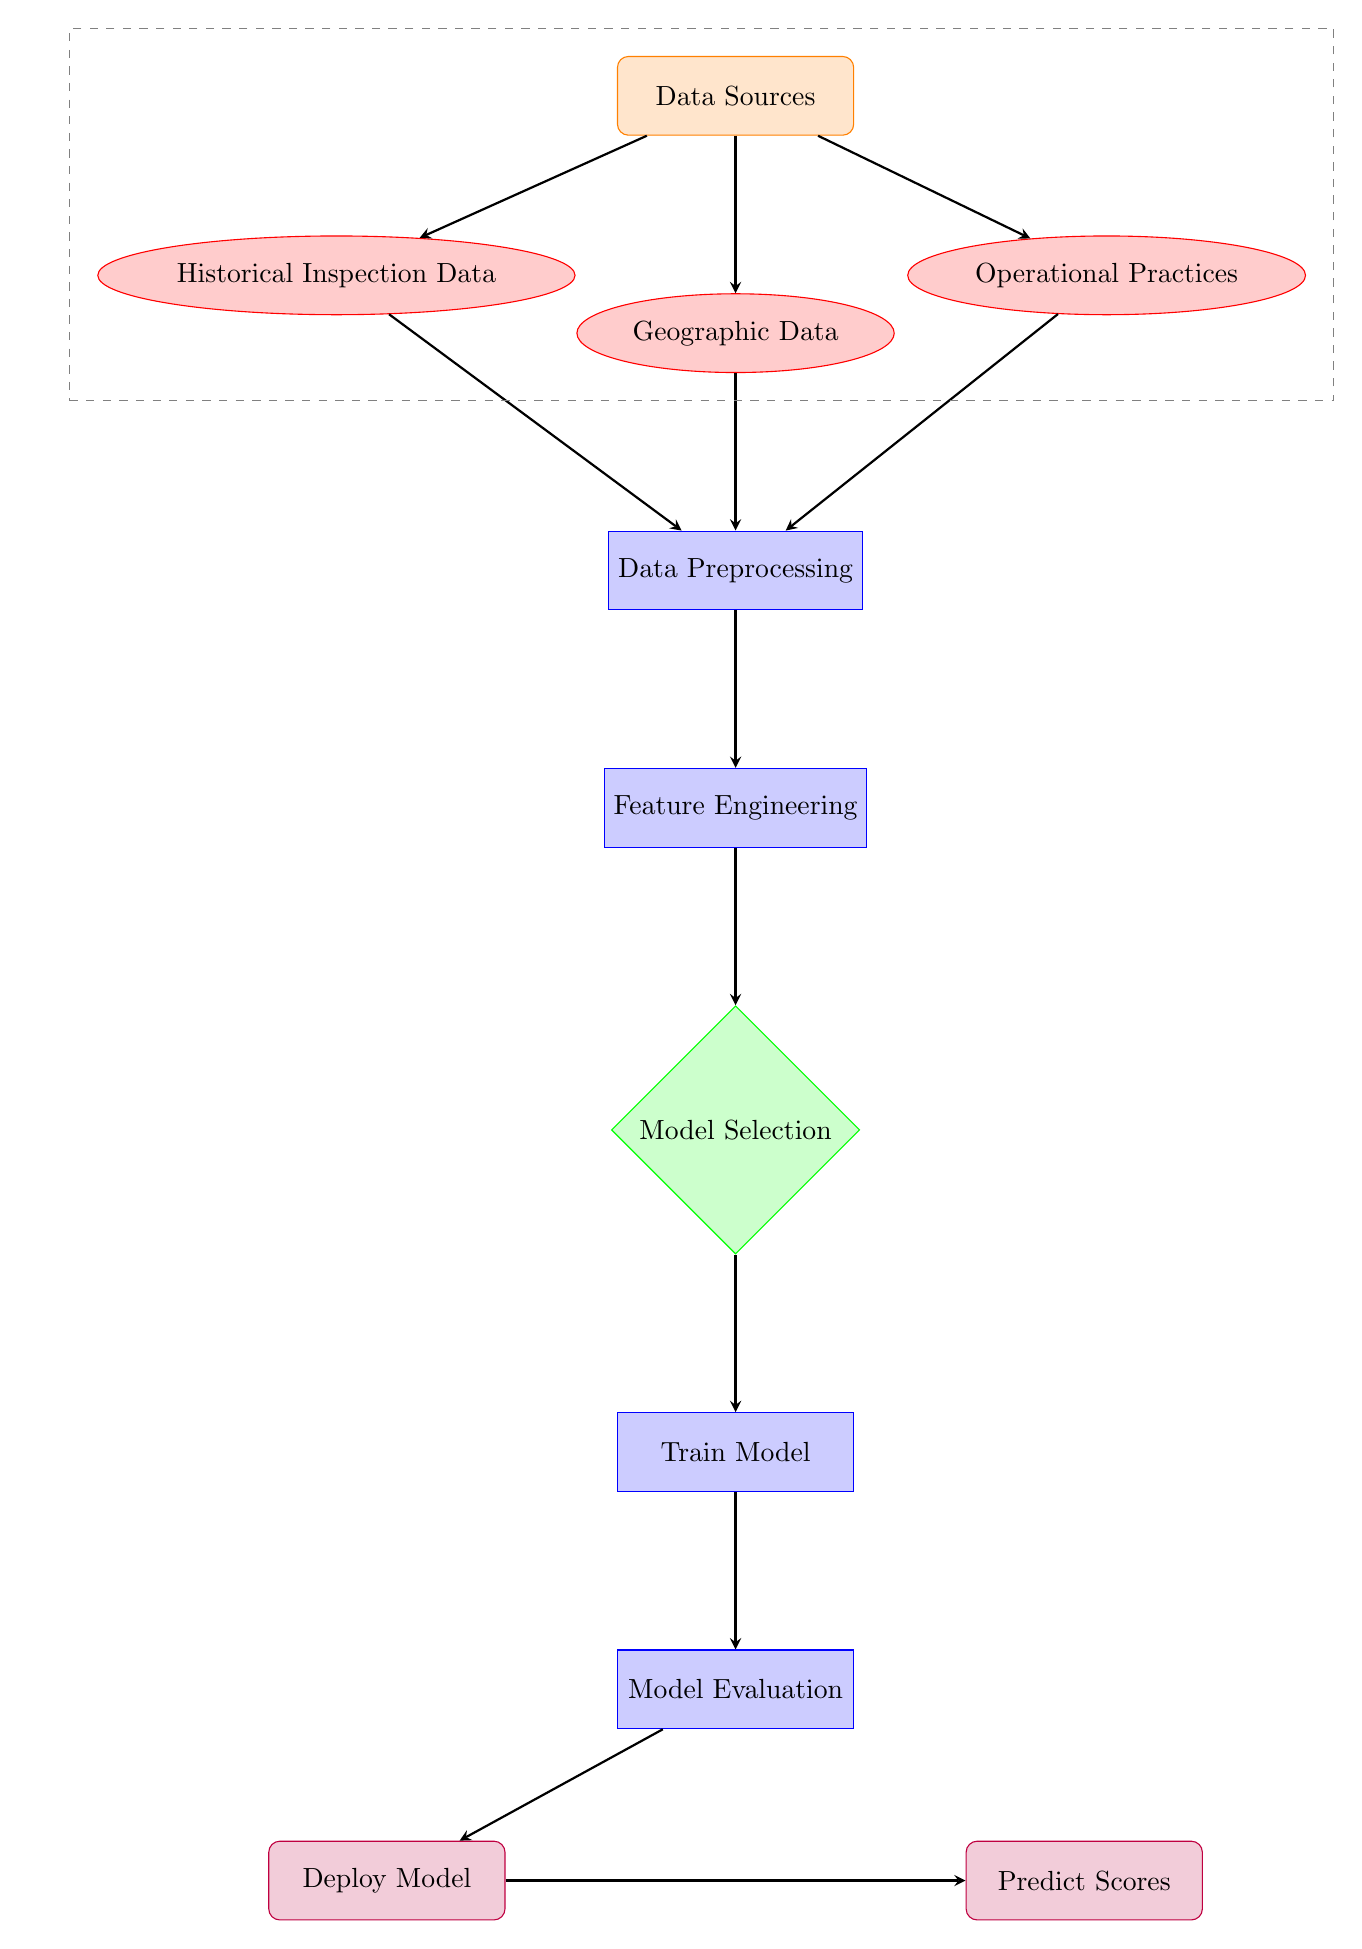What are the main data sources for this model? The main data sources labeled in the diagram are "Historical Inspection Data," "Geographic Data," and "Operational Practices." These nodes are connected to the "Data Sources" node and represent the types of information used.
Answer: Historical Inspection Data, Geographic Data, Operational Practices What is the first process in the workflow? The first process in the workflow follows the data sources and is titled "Data Preprocessing." This node comes directly after the input data sources.
Answer: Data Preprocessing How many output nodes are there in the diagram? There are two output nodes in the diagram represented by "Deploy Model" and "Predict Scores." The diagram clearly shows these nodes placed below the "Model Evaluation" process.
Answer: 2 Which process comes after feature engineering? The process that follows "Feature Engineering" is "Model Selection." This is a direct connection in the flow of the diagram showing the sequence of operations.
Answer: Model Selection What do you do after training the model? After training the model, the next step is "Model Evaluation." This step assesses the performance of the trained model.
Answer: Model Evaluation How does geographic data contribute to the model? Geographic data contributes by passing through the "Data Preprocessing" process. It is combined with the other data sources to prepare for feature engineering, impacting later model predictions.
Answer: Preprocessing What is the purpose of the output "Deploy Model"? The purpose of the output node "Deploy Model" is to make the trained model available for use after evaluation. It represents a stage where the model is implemented practically.
Answer: Model Deployment What step involves improving the model's predictive features? The step that focuses on improving the model's predictive features is "Feature Engineering." This process involves transforming raw data into structured inputs for the model.
Answer: Feature Engineering What flows into the model selection process? The "Feature Engineering" step flows into the "Model Selection" process. This indicates that model selection occurs after the features have been engineered.
Answer: Feature Engineering 